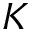Convert formula to latex. <formula><loc_0><loc_0><loc_500><loc_500>K</formula> 